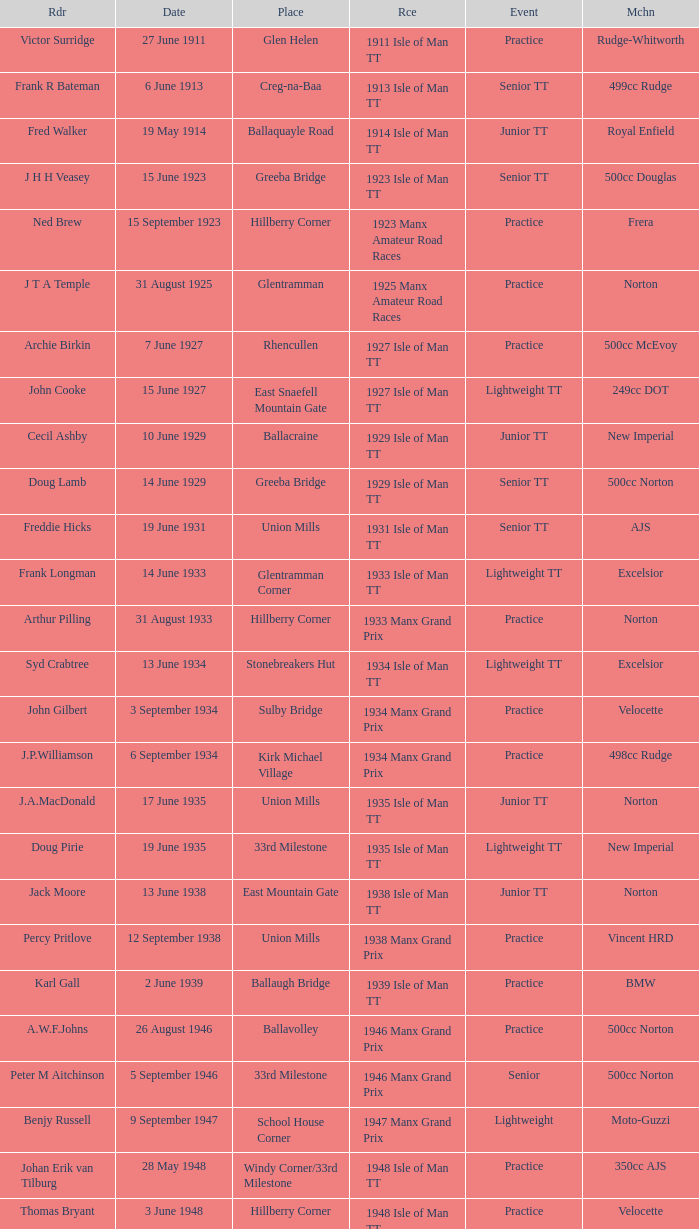What machine did Kenneth E. Herbert ride? 499cc Norton. 